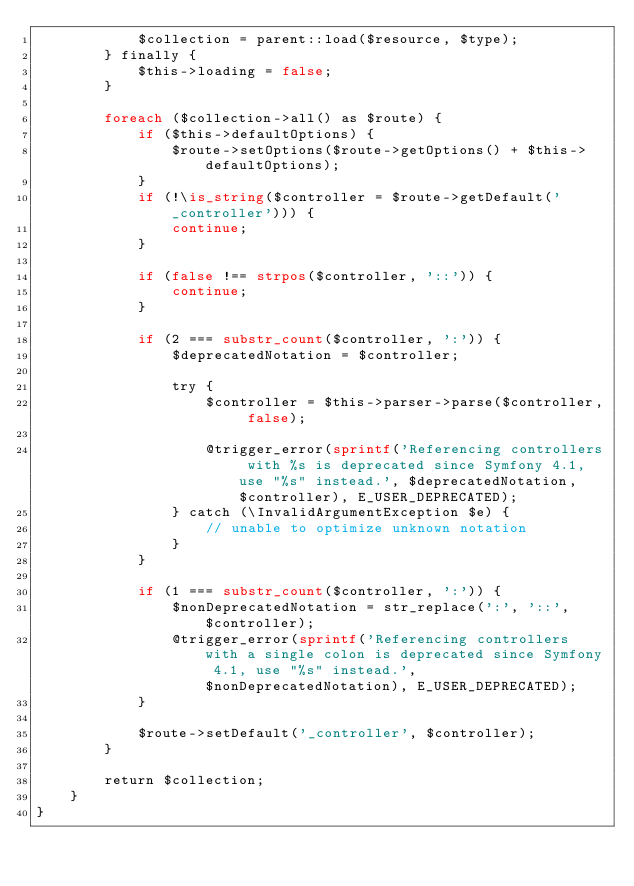<code> <loc_0><loc_0><loc_500><loc_500><_PHP_>            $collection = parent::load($resource, $type);
        } finally {
            $this->loading = false;
        }

        foreach ($collection->all() as $route) {
            if ($this->defaultOptions) {
                $route->setOptions($route->getOptions() + $this->defaultOptions);
            }
            if (!\is_string($controller = $route->getDefault('_controller'))) {
                continue;
            }

            if (false !== strpos($controller, '::')) {
                continue;
            }

            if (2 === substr_count($controller, ':')) {
                $deprecatedNotation = $controller;

                try {
                    $controller = $this->parser->parse($controller, false);

                    @trigger_error(sprintf('Referencing controllers with %s is deprecated since Symfony 4.1, use "%s" instead.', $deprecatedNotation, $controller), E_USER_DEPRECATED);
                } catch (\InvalidArgumentException $e) {
                    // unable to optimize unknown notation
                }
            }

            if (1 === substr_count($controller, ':')) {
                $nonDeprecatedNotation = str_replace(':', '::', $controller);
                @trigger_error(sprintf('Referencing controllers with a single colon is deprecated since Symfony 4.1, use "%s" instead.', $nonDeprecatedNotation), E_USER_DEPRECATED);
            }

            $route->setDefault('_controller', $controller);
        }

        return $collection;
    }
}
</code> 